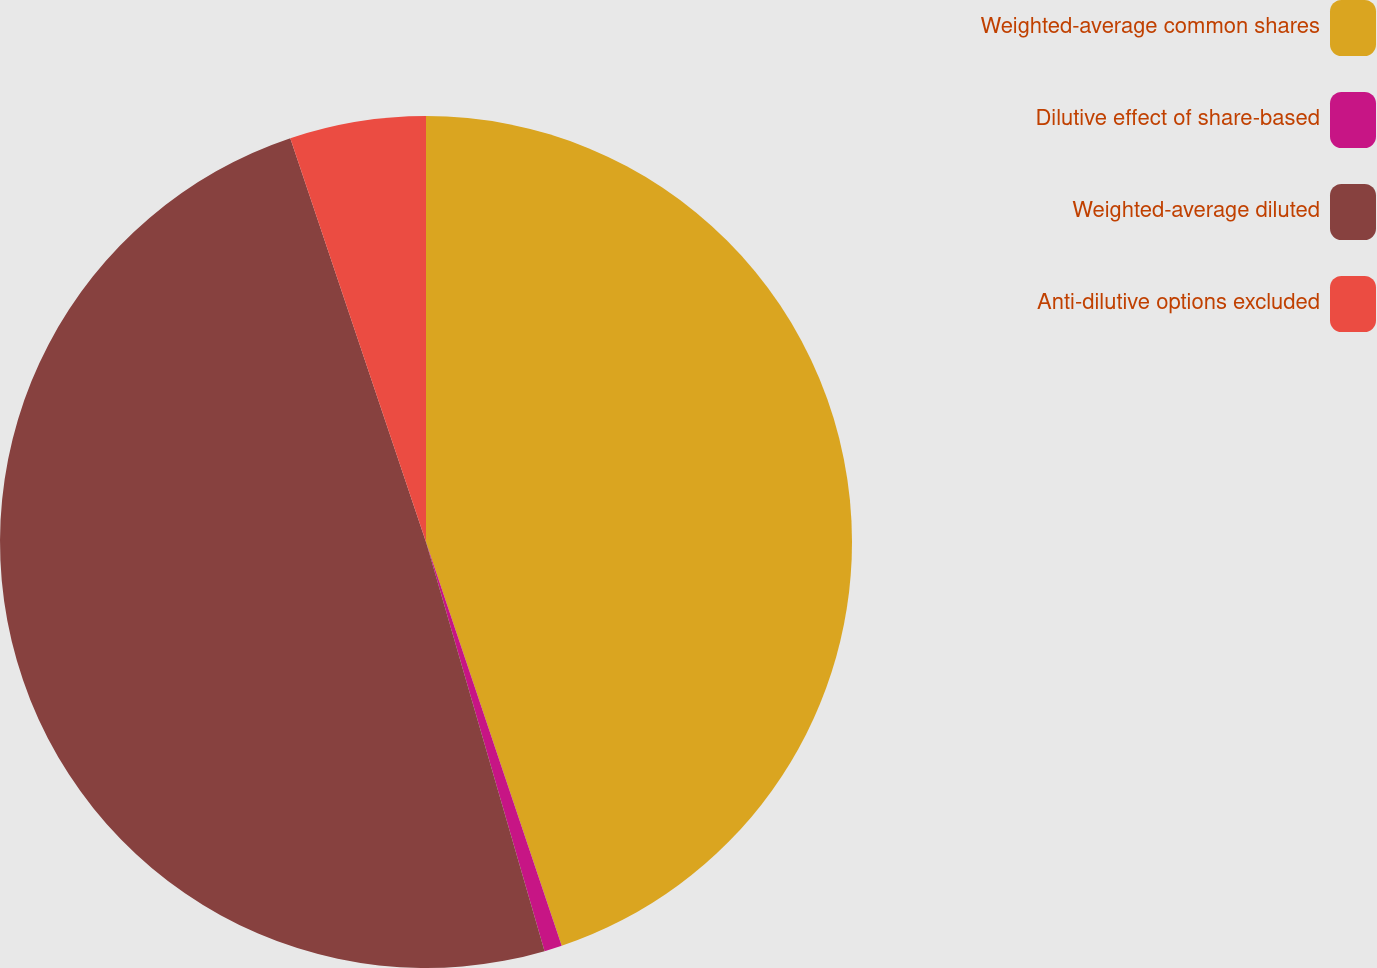Convert chart. <chart><loc_0><loc_0><loc_500><loc_500><pie_chart><fcel>Weighted-average common shares<fcel>Dilutive effect of share-based<fcel>Weighted-average diluted<fcel>Anti-dilutive options excluded<nl><fcel>44.84%<fcel>0.67%<fcel>49.33%<fcel>5.16%<nl></chart> 